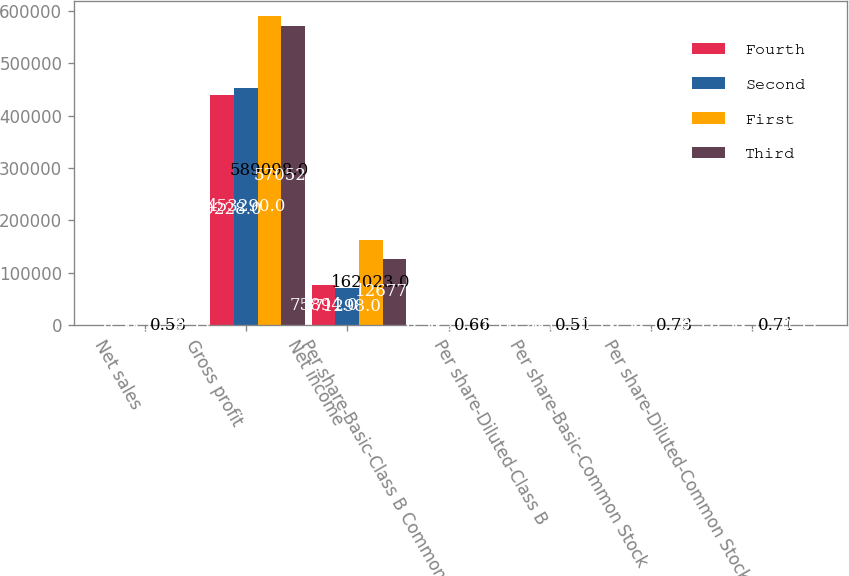Convert chart to OTSL. <chart><loc_0><loc_0><loc_500><loc_500><stacked_bar_chart><ecel><fcel>Net sales<fcel>Gross profit<fcel>Net income<fcel>Per share-Basic-Class B Common<fcel>Per share-Diluted-Class B<fcel>Per share-Basic-Common Stock<fcel>Per share-Diluted-Common Stock<nl><fcel>Fourth<fcel>0.53<fcel>440228<fcel>75894<fcel>0.31<fcel>0.26<fcel>0.34<fcel>0.33<nl><fcel>Second<fcel>0.53<fcel>453290<fcel>71298<fcel>0.29<fcel>0.17<fcel>0.32<fcel>0.31<nl><fcel>First<fcel>0.53<fcel>589098<fcel>162023<fcel>0.66<fcel>0.51<fcel>0.73<fcel>0.71<nl><fcel>Third<fcel>0.53<fcel>570521<fcel>126779<fcel>0.51<fcel>0.33<fcel>0.57<fcel>0.55<nl></chart> 